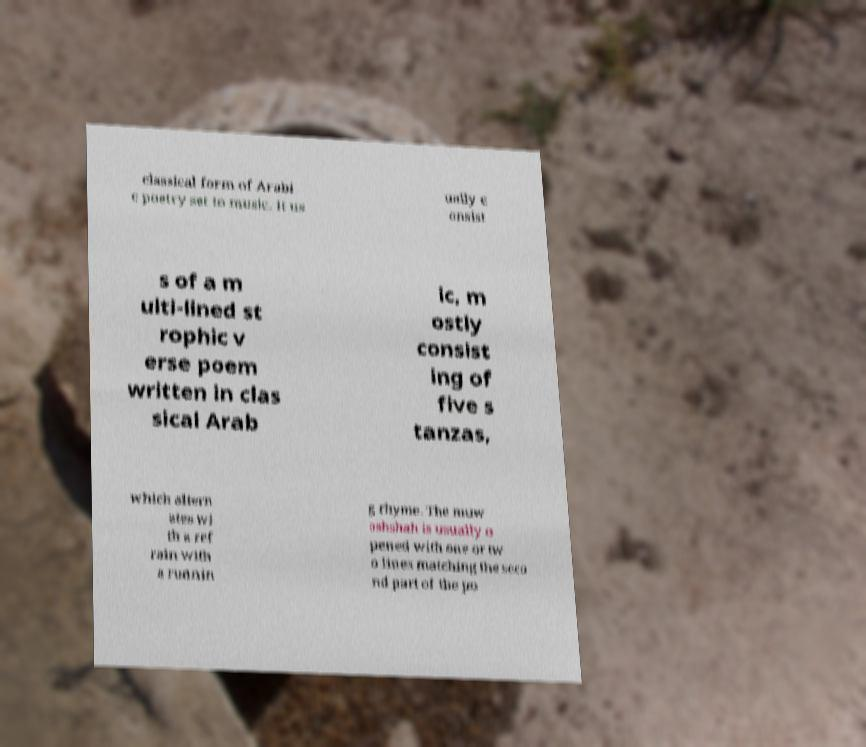What messages or text are displayed in this image? I need them in a readable, typed format. classical form of Arabi c poetry set to music. It us ually c onsist s of a m ulti-lined st rophic v erse poem written in clas sical Arab ic, m ostly consist ing of five s tanzas, which altern ates wi th a ref rain with a runnin g rhyme. The muw ashshah is usually o pened with one or tw o lines matching the seco nd part of the po 